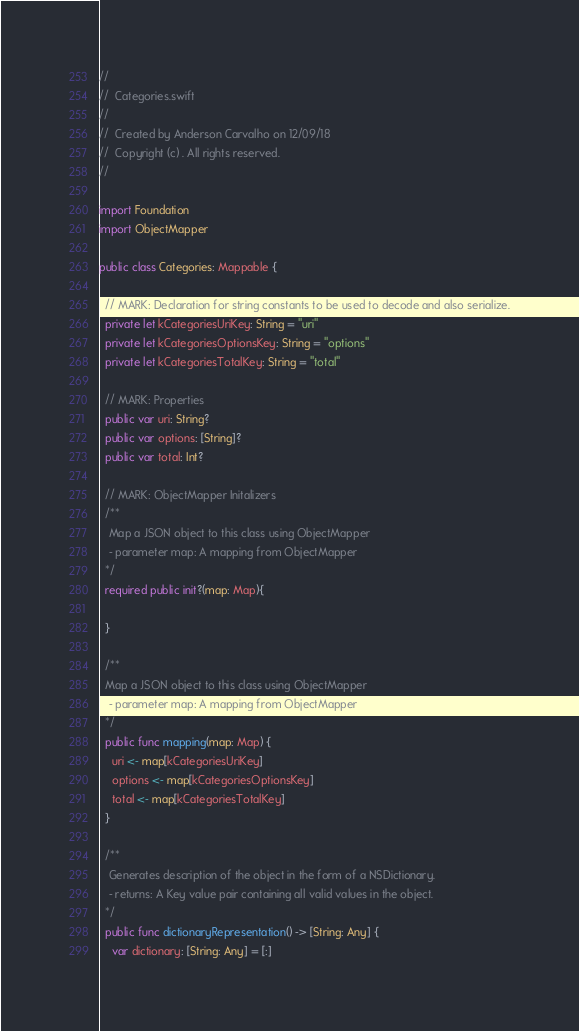<code> <loc_0><loc_0><loc_500><loc_500><_Swift_>//
//  Categories.swift
//
//  Created by Anderson Carvalho on 12/09/18
//  Copyright (c) . All rights reserved.
//

import Foundation
import ObjectMapper

public class Categories: Mappable {

  // MARK: Declaration for string constants to be used to decode and also serialize.
  private let kCategoriesUriKey: String = "uri"
  private let kCategoriesOptionsKey: String = "options"
  private let kCategoriesTotalKey: String = "total"

  // MARK: Properties
  public var uri: String?
  public var options: [String]?
  public var total: Int?

  // MARK: ObjectMapper Initalizers
  /**
   Map a JSON object to this class using ObjectMapper
   - parameter map: A mapping from ObjectMapper
  */
  required public init?(map: Map){

  }

  /**
  Map a JSON object to this class using ObjectMapper
   - parameter map: A mapping from ObjectMapper
  */
  public func mapping(map: Map) {
    uri <- map[kCategoriesUriKey]
    options <- map[kCategoriesOptionsKey]
    total <- map[kCategoriesTotalKey]
  }

  /**
   Generates description of the object in the form of a NSDictionary.
   - returns: A Key value pair containing all valid values in the object.
  */
  public func dictionaryRepresentation() -> [String: Any] {
    var dictionary: [String: Any] = [:]</code> 